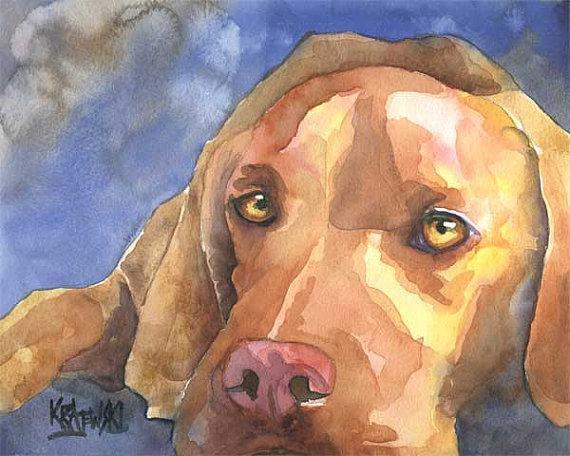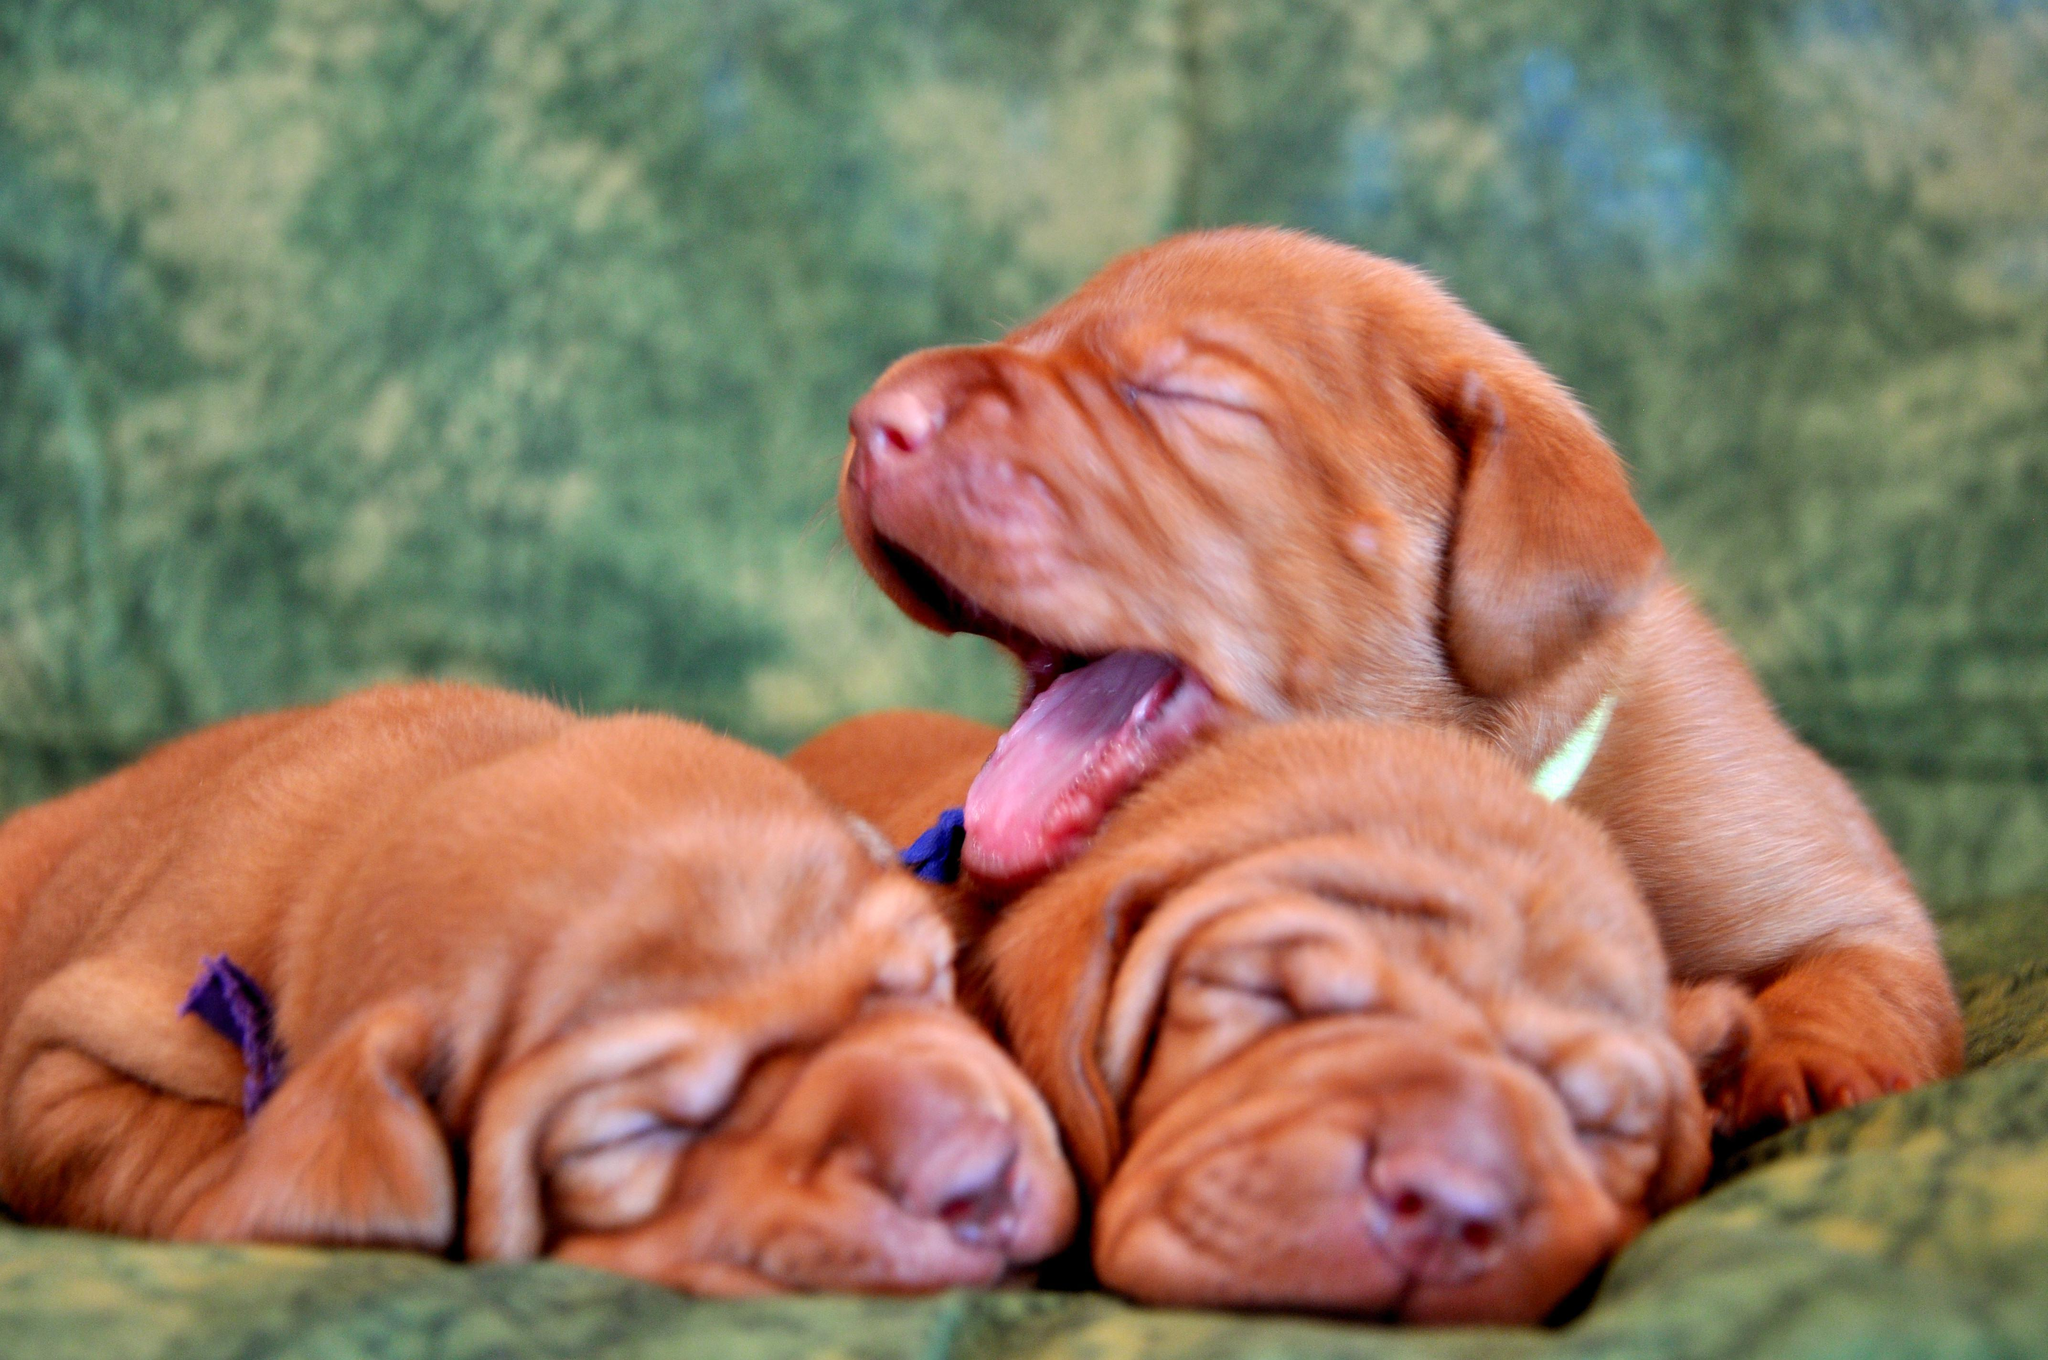The first image is the image on the left, the second image is the image on the right. For the images shown, is this caption "The dog in the image on the left is lying down on a blue material." true? Answer yes or no. Yes. The first image is the image on the left, the second image is the image on the right. For the images shown, is this caption "The left and right image contains the same number of dogs and at least one is a puppy." true? Answer yes or no. No. 